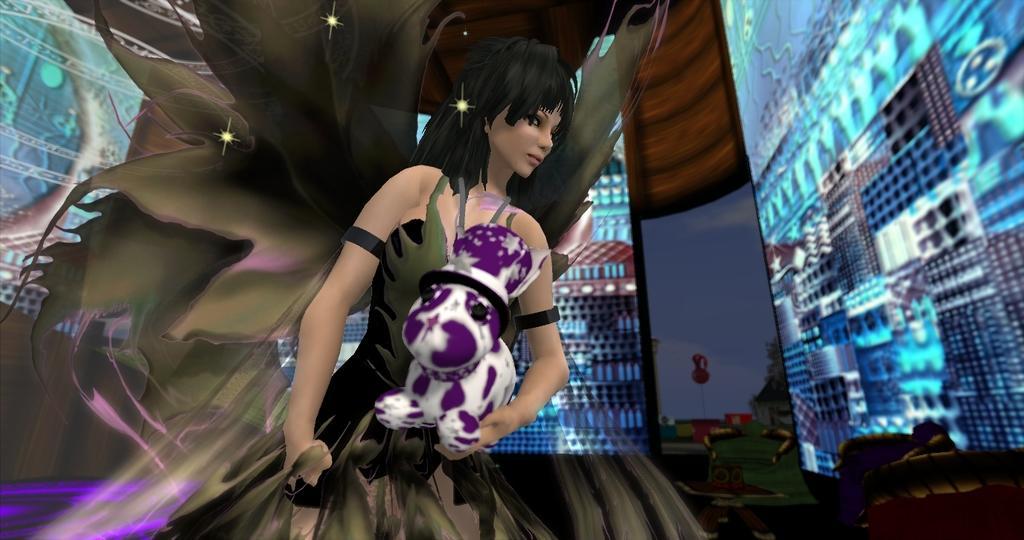How would you summarize this image in a sentence or two? Here this is an animated image, in which we can see an animated picture of a woman holding a teddy bear present over there and we can also see other themes present. 